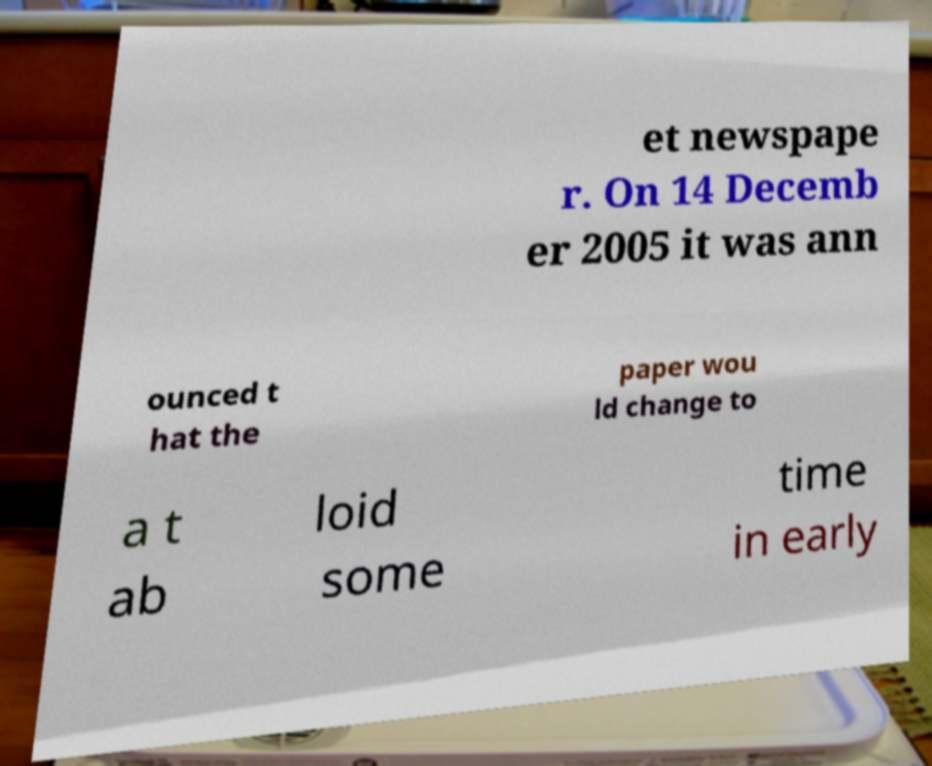Could you extract and type out the text from this image? et newspape r. On 14 Decemb er 2005 it was ann ounced t hat the paper wou ld change to a t ab loid some time in early 